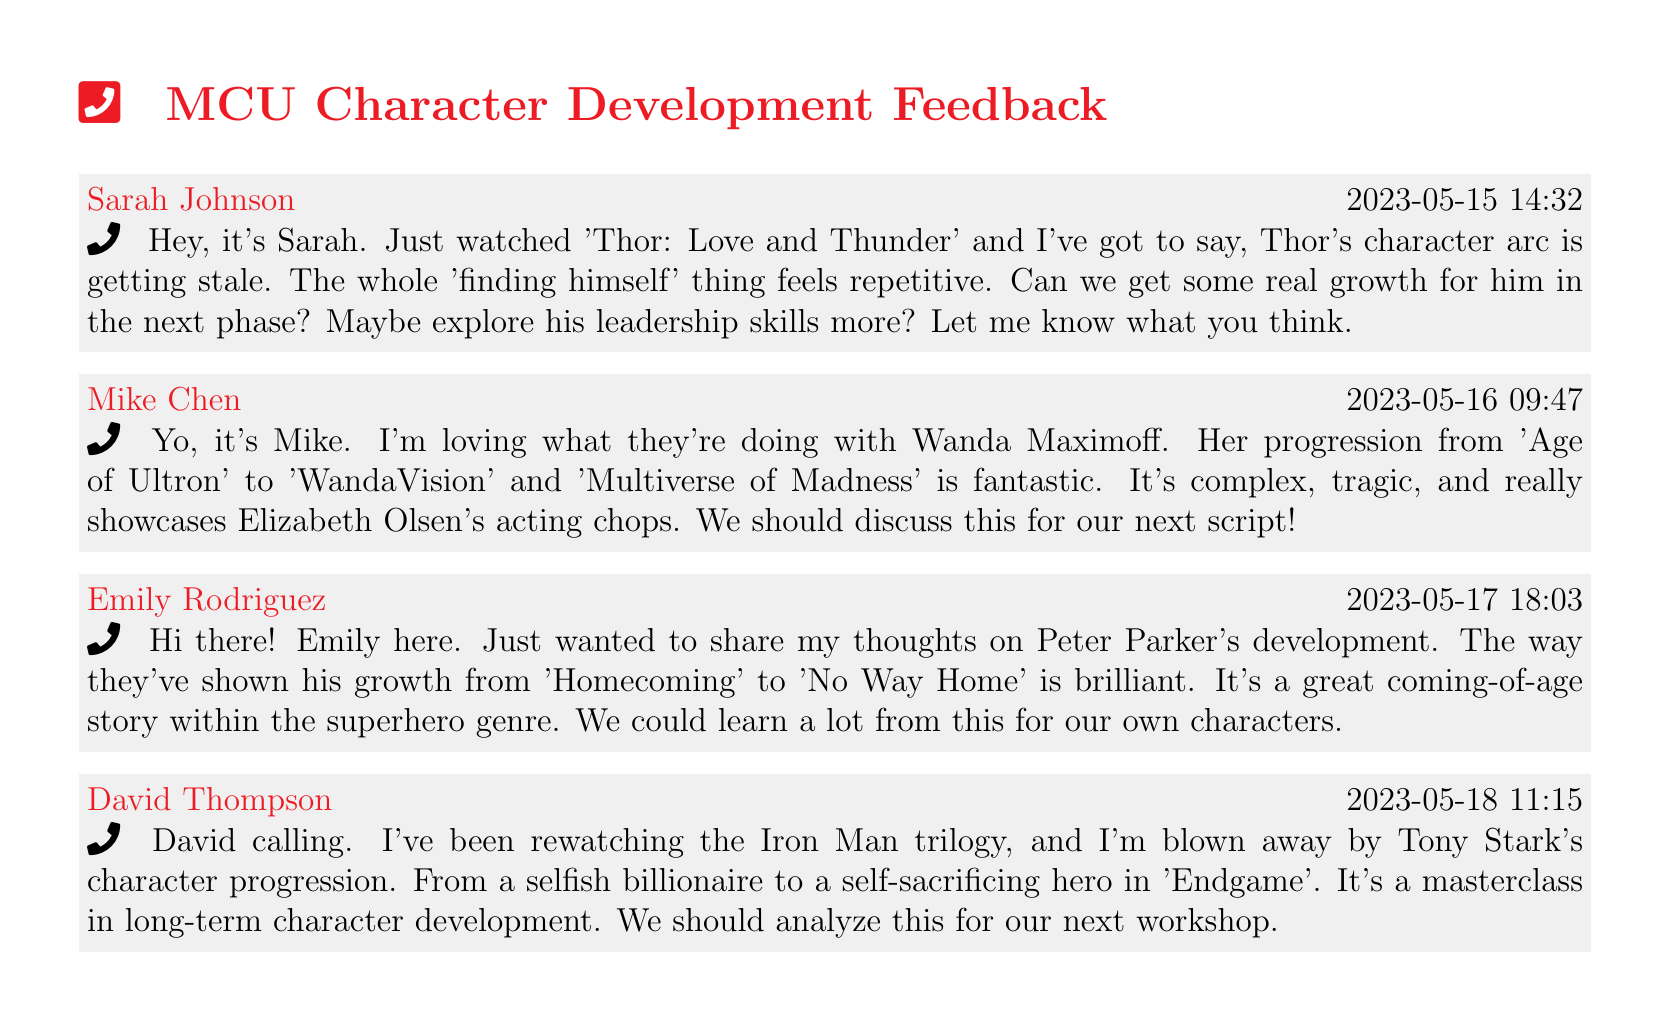What date did Sarah Johnson call? Sarah Johnson left her voicemail on May 15, 2023.
Answer: 2023-05-15 What character's development did Mike Chen appreciate? Mike Chen highlighted Wanda Maximoff's character progression.
Answer: Wanda Maximoff What was Emily Rodriguez's opinion on Peter Parker's growth? Emily felt that Peter Parker's development was a brilliant coming-of-age story.
Answer: Coming-of-age story How many voicemail entries are there in the document? There are four voicemail entries listed in the document.
Answer: 4 Which character's arc did Sarah Johnson find repetitive? Sarah mentioned that Thor's character arc feels repetitive.
Answer: Thor What transformation did David Thompson note in Tony Stark's character? David noted Tony Stark's transformation from selfish billionaire to self-sacrificing hero.
Answer: Self-sacrificing hero Which MCU film did Emily Rodriguez mention in her feedback? Emily referred to 'No Way Home' when discussing Peter Parker.
Answer: No Way Home What does Mike Chen suggest regarding Wanda Maximoff? Mike suggests discussing Wanda Maximoff's progression for their next script.
Answer: Discuss this for our next script 